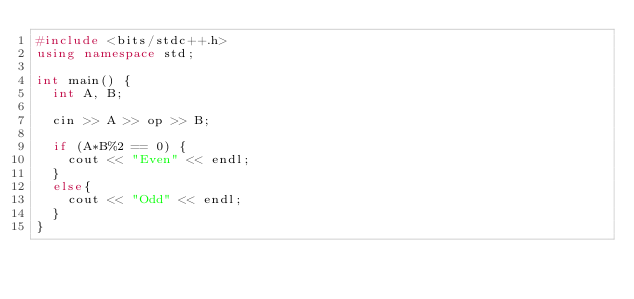<code> <loc_0><loc_0><loc_500><loc_500><_C++_>#include <bits/stdc++.h>
using namespace std;

int main() {
  int A, B;
  
  cin >> A >> op >> B;

  if (A*B%2 == 0) {
    cout << "Even" << endl;
  }
  else{
    cout << "Odd" << endl;
  }  
}
  </code> 